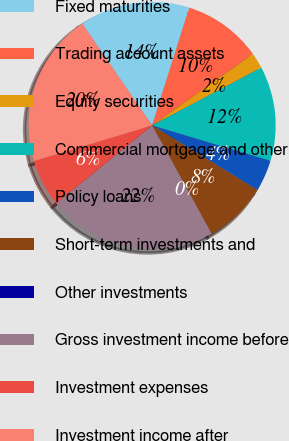Convert chart to OTSL. <chart><loc_0><loc_0><loc_500><loc_500><pie_chart><fcel>Fixed maturities<fcel>Trading account assets<fcel>Equity securities<fcel>Commercial mortgage and other<fcel>Policy loans<fcel>Short-term investments and<fcel>Other investments<fcel>Gross investment income before<fcel>Investment expenses<fcel>Investment income after<nl><fcel>14.45%<fcel>10.32%<fcel>2.07%<fcel>12.38%<fcel>4.13%<fcel>8.26%<fcel>0.0%<fcel>22.13%<fcel>6.19%<fcel>20.07%<nl></chart> 